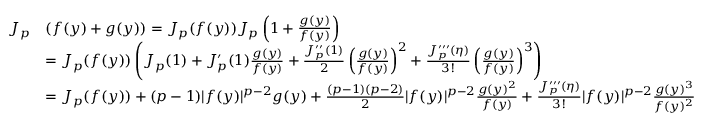<formula> <loc_0><loc_0><loc_500><loc_500>\begin{array} { r l } { J _ { p } } & { ( f ( y ) + g ( y ) ) = J _ { p } ( f ( y ) ) J _ { p } \left ( 1 + \frac { g ( y ) } { f ( y ) } \right ) } \\ & { = J _ { p } ( f ( y ) ) \left ( J _ { p } ( 1 ) + J _ { p } ^ { \prime } ( 1 ) \frac { g ( y ) } { f ( y ) } + \frac { J _ { p } ^ { \prime \prime } ( 1 ) } { 2 } \left ( \frac { g ( y ) } { f ( y ) } \right ) ^ { 2 } + \frac { J _ { p } ^ { \prime \prime \prime } ( \eta ) } { 3 ! } \left ( \frac { g ( y ) } { f ( y ) } \right ) ^ { 3 } \right ) } \\ & { = J _ { p } ( f ( y ) ) + ( p - 1 ) | f ( y ) | ^ { p - 2 } g ( y ) + \frac { ( p - 1 ) ( p - 2 ) } { 2 } | f ( y ) | ^ { p - 2 } \frac { g ( y ) ^ { 2 } } { f ( y ) } + \frac { J _ { p } ^ { \prime \prime \prime } ( \eta ) } { 3 ! } | f ( y ) | ^ { p - 2 } \frac { g ( y ) ^ { 3 } } { f ( y ) ^ { 2 } } } \end{array}</formula> 